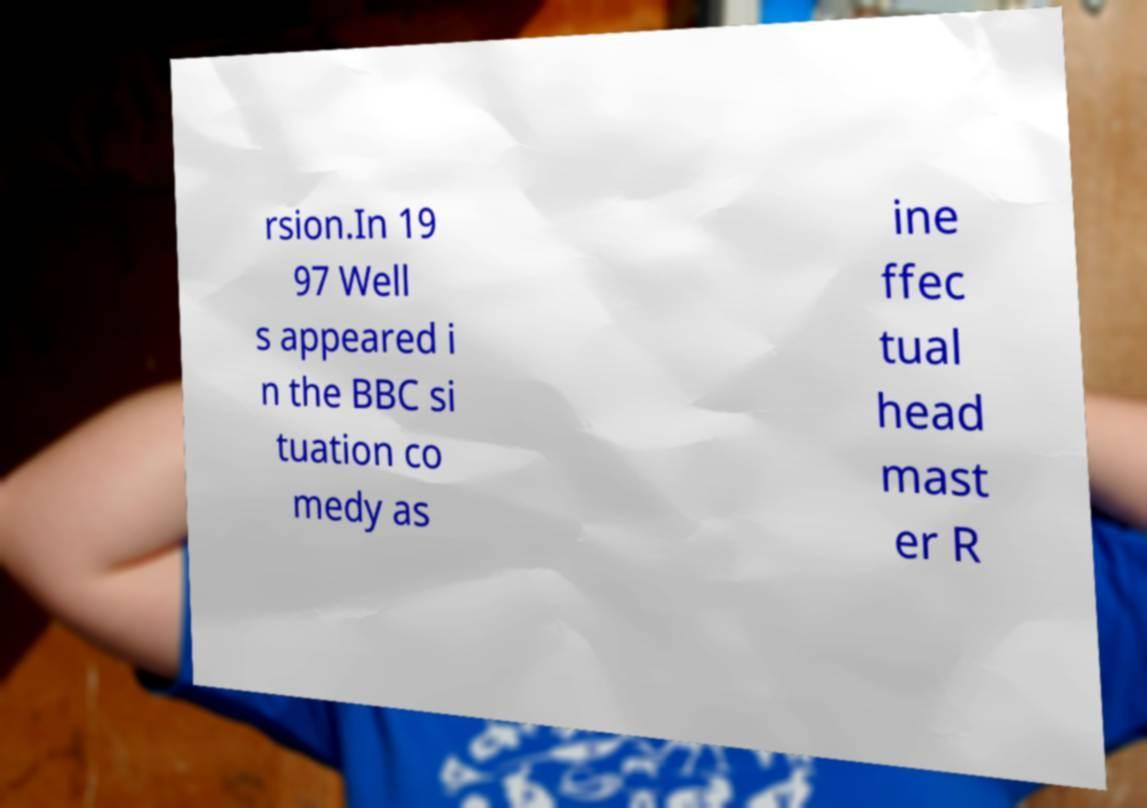Could you assist in decoding the text presented in this image and type it out clearly? rsion.In 19 97 Well s appeared i n the BBC si tuation co medy as ine ffec tual head mast er R 